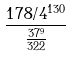<formula> <loc_0><loc_0><loc_500><loc_500>\frac { 1 7 8 / 4 ^ { 1 3 0 } } { \frac { 3 7 ^ { 9 } } { 3 2 2 } }</formula> 